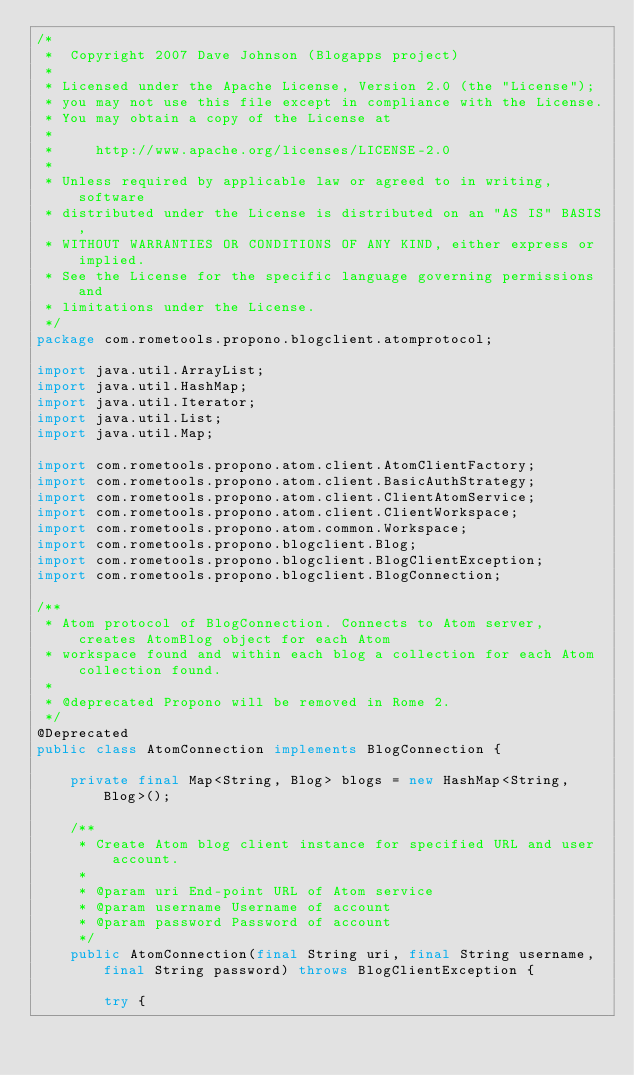Convert code to text. <code><loc_0><loc_0><loc_500><loc_500><_Java_>/*
 *  Copyright 2007 Dave Johnson (Blogapps project)
 *
 * Licensed under the Apache License, Version 2.0 (the "License");
 * you may not use this file except in compliance with the License.
 * You may obtain a copy of the License at
 *
 *     http://www.apache.org/licenses/LICENSE-2.0
 *
 * Unless required by applicable law or agreed to in writing, software
 * distributed under the License is distributed on an "AS IS" BASIS,
 * WITHOUT WARRANTIES OR CONDITIONS OF ANY KIND, either express or implied.
 * See the License for the specific language governing permissions and
 * limitations under the License.
 */
package com.rometools.propono.blogclient.atomprotocol;

import java.util.ArrayList;
import java.util.HashMap;
import java.util.Iterator;
import java.util.List;
import java.util.Map;

import com.rometools.propono.atom.client.AtomClientFactory;
import com.rometools.propono.atom.client.BasicAuthStrategy;
import com.rometools.propono.atom.client.ClientAtomService;
import com.rometools.propono.atom.client.ClientWorkspace;
import com.rometools.propono.atom.common.Workspace;
import com.rometools.propono.blogclient.Blog;
import com.rometools.propono.blogclient.BlogClientException;
import com.rometools.propono.blogclient.BlogConnection;

/**
 * Atom protocol of BlogConnection. Connects to Atom server, creates AtomBlog object for each Atom
 * workspace found and within each blog a collection for each Atom collection found.
 *
 * @deprecated Propono will be removed in Rome 2.
 */
@Deprecated
public class AtomConnection implements BlogConnection {

    private final Map<String, Blog> blogs = new HashMap<String, Blog>();

    /**
     * Create Atom blog client instance for specified URL and user account.
     *
     * @param uri End-point URL of Atom service
     * @param username Username of account
     * @param password Password of account
     */
    public AtomConnection(final String uri, final String username, final String password) throws BlogClientException {

        try {</code> 